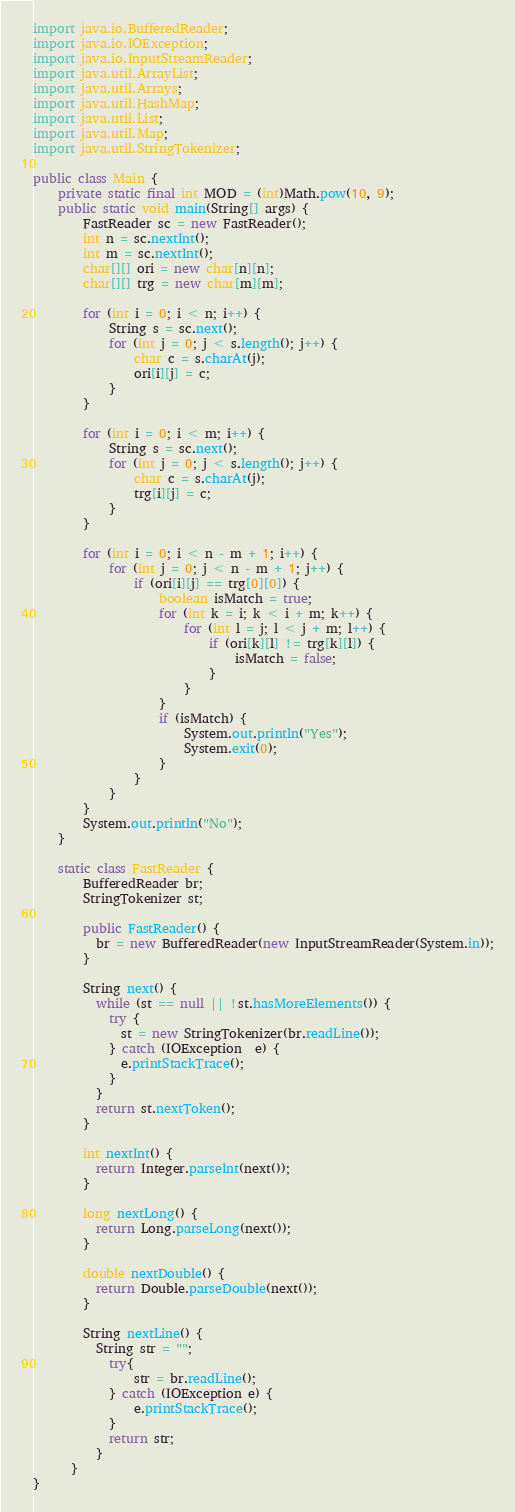Convert code to text. <code><loc_0><loc_0><loc_500><loc_500><_Java_>import java.io.BufferedReader;
import java.io.IOException;
import java.io.InputStreamReader;
import java.util.ArrayList;
import java.util.Arrays;
import java.util.HashMap;
import java.util.List;
import java.util.Map;
import java.util.StringTokenizer;

public class Main {
	private static final int MOD = (int)Math.pow(10, 9);
	public static void main(String[] args) {
		FastReader sc = new FastReader();
		int n = sc.nextInt();
		int m = sc.nextInt();
		char[][] ori = new char[n][n];
		char[][] trg = new char[m][m];
		
		for (int i = 0; i < n; i++) {
			String s = sc.next();
			for (int j = 0; j < s.length(); j++) {
				char c = s.charAt(j);
				ori[i][j] = c;
			}
		}
		
		for (int i = 0; i < m; i++) {
			String s = sc.next();
			for (int j = 0; j < s.length(); j++) {
				char c = s.charAt(j);
				trg[i][j] = c;
			}
		}
		
		for (int i = 0; i < n - m + 1; i++) {
			for (int j = 0; j < n - m + 1; j++) {
				if (ori[i][j] == trg[0][0]) {
					boolean isMatch = true;
					for (int k = i; k < i + m; k++) {
						for (int l = j; l < j + m; l++) {
							if (ori[k][l] != trg[k][l]) {
								isMatch = false;
							}
						}
					}
					if (isMatch) {
						System.out.println("Yes");
						System.exit(0);
					}
				}
			}
		}
		System.out.println("No");
	}
	
	static class FastReader {
	    BufferedReader br;
	    StringTokenizer st;
	
	    public FastReader() {
	      br = new BufferedReader(new InputStreamReader(System.in));
	    }
	  
	    String next() { 
	      while (st == null || !st.hasMoreElements()) {
	        try {
	          st = new StringTokenizer(br.readLine());
	        } catch (IOException  e) {
	          e.printStackTrace();
	        }
	      }
	      return st.nextToken();
	    }
	
	    int nextInt() {
	      return Integer.parseInt(next());
	    }
	
	    long nextLong() {
	      return Long.parseLong(next());
	    }
	
	    double nextDouble() { 
	      return Double.parseDouble(next());
	    }
	
	    String nextLine() {
	      String str = "";
	        try{
	            str = br.readLine();
	        } catch (IOException e) {
	            e.printStackTrace();
	        }
	        return str;
	      }
	  }
}
</code> 